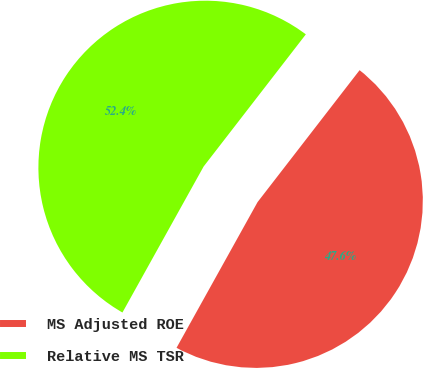<chart> <loc_0><loc_0><loc_500><loc_500><pie_chart><fcel>MS Adjusted ROE<fcel>Relative MS TSR<nl><fcel>47.6%<fcel>52.4%<nl></chart> 